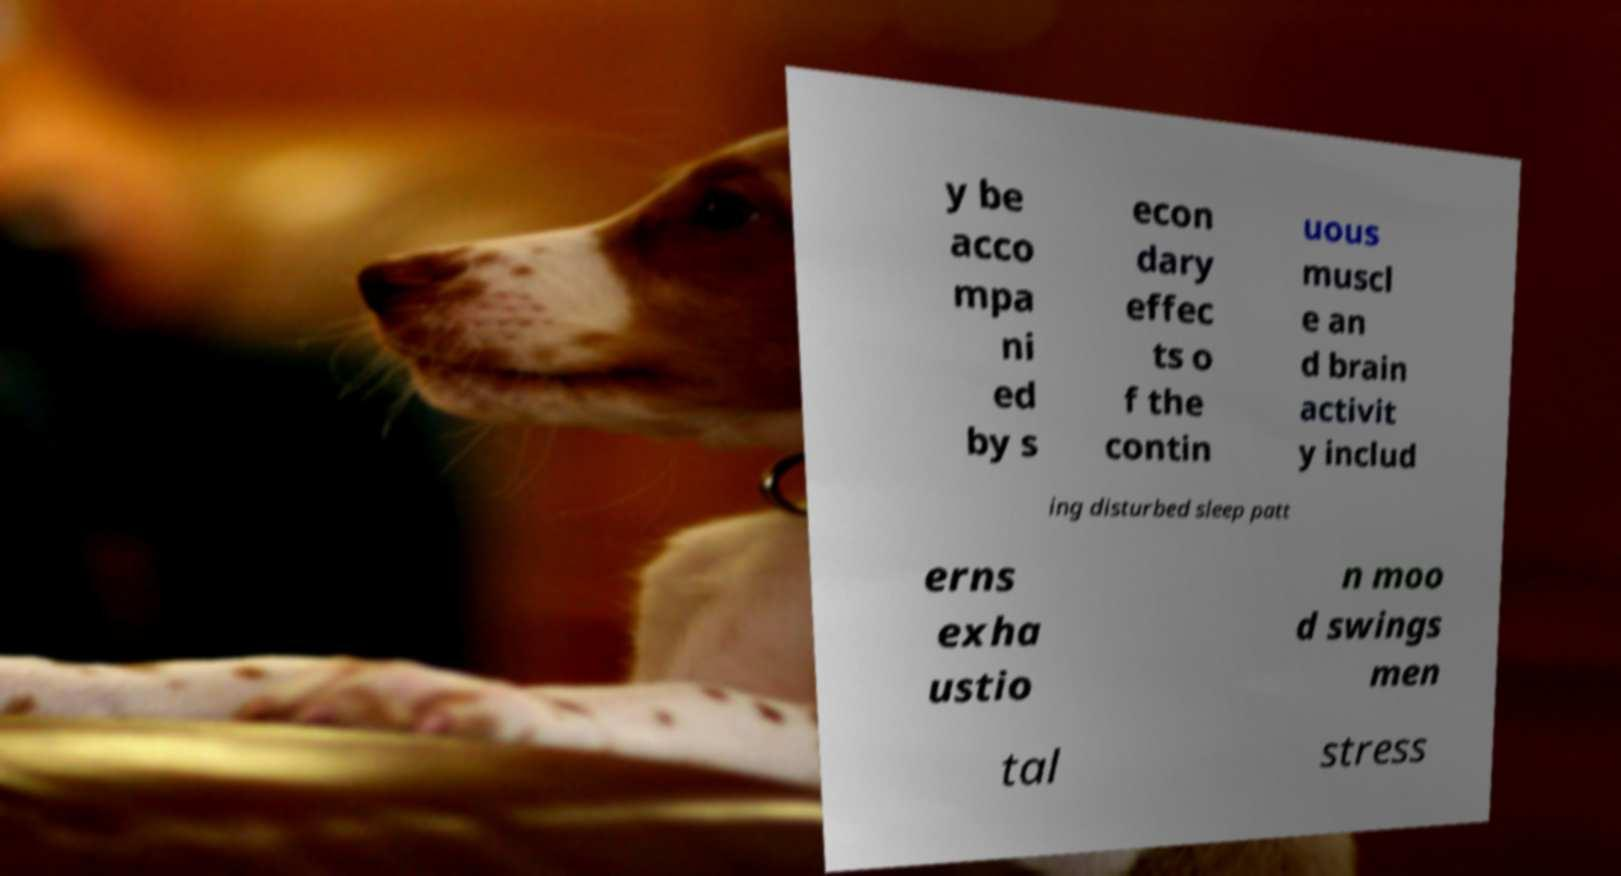Could you extract and type out the text from this image? y be acco mpa ni ed by s econ dary effec ts o f the contin uous muscl e an d brain activit y includ ing disturbed sleep patt erns exha ustio n moo d swings men tal stress 